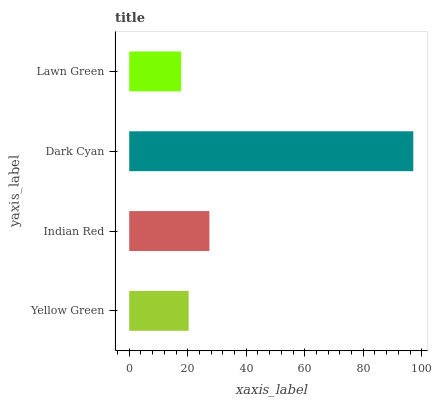Is Lawn Green the minimum?
Answer yes or no. Yes. Is Dark Cyan the maximum?
Answer yes or no. Yes. Is Indian Red the minimum?
Answer yes or no. No. Is Indian Red the maximum?
Answer yes or no. No. Is Indian Red greater than Yellow Green?
Answer yes or no. Yes. Is Yellow Green less than Indian Red?
Answer yes or no. Yes. Is Yellow Green greater than Indian Red?
Answer yes or no. No. Is Indian Red less than Yellow Green?
Answer yes or no. No. Is Indian Red the high median?
Answer yes or no. Yes. Is Yellow Green the low median?
Answer yes or no. Yes. Is Lawn Green the high median?
Answer yes or no. No. Is Dark Cyan the low median?
Answer yes or no. No. 